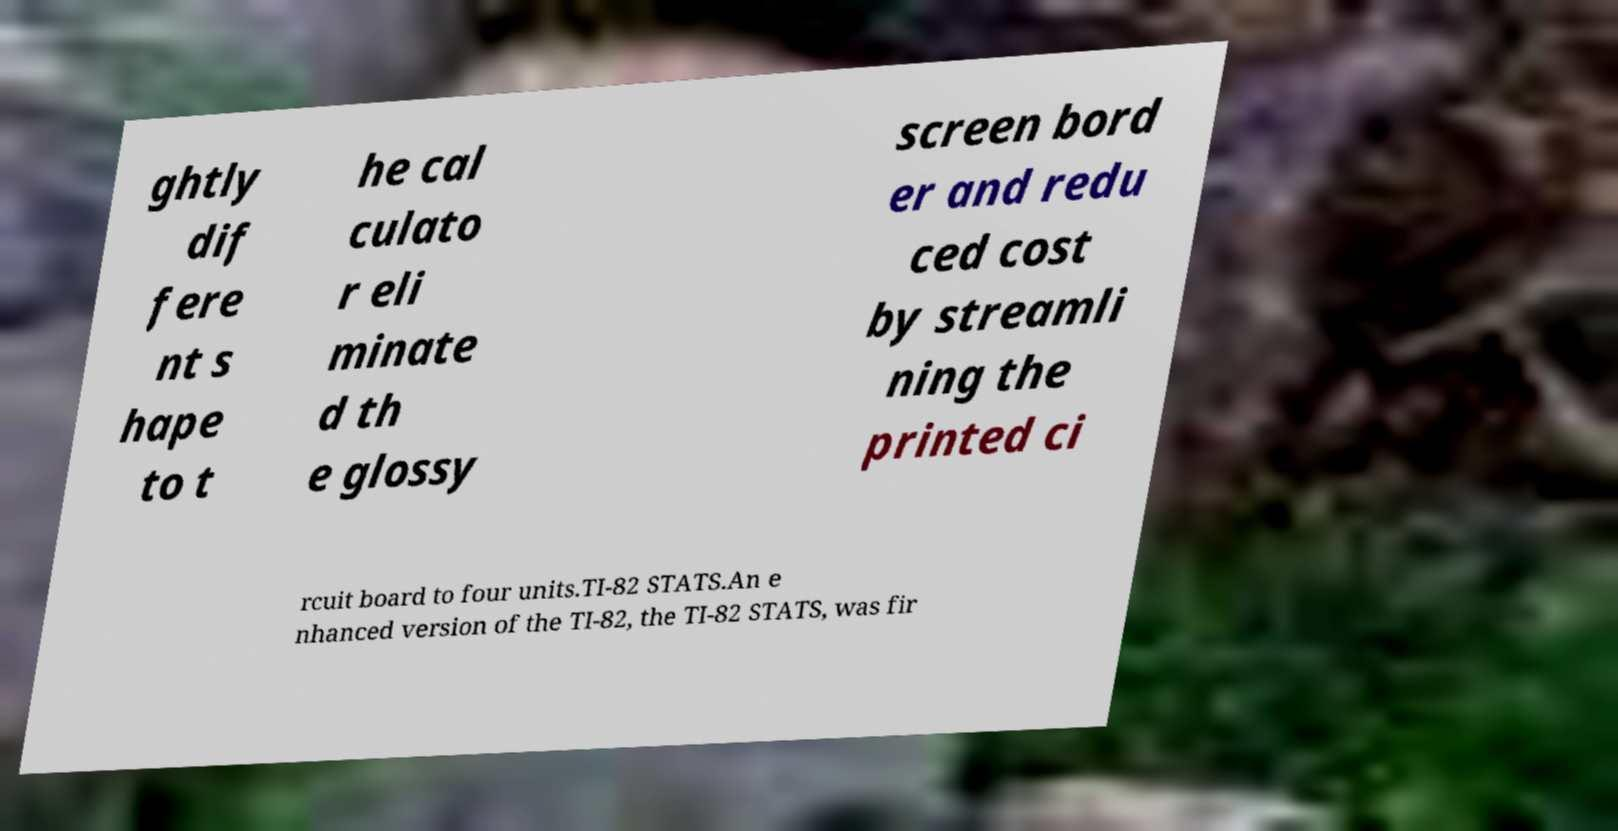What messages or text are displayed in this image? I need them in a readable, typed format. ghtly dif fere nt s hape to t he cal culato r eli minate d th e glossy screen bord er and redu ced cost by streamli ning the printed ci rcuit board to four units.TI-82 STATS.An e nhanced version of the TI-82, the TI-82 STATS, was fir 